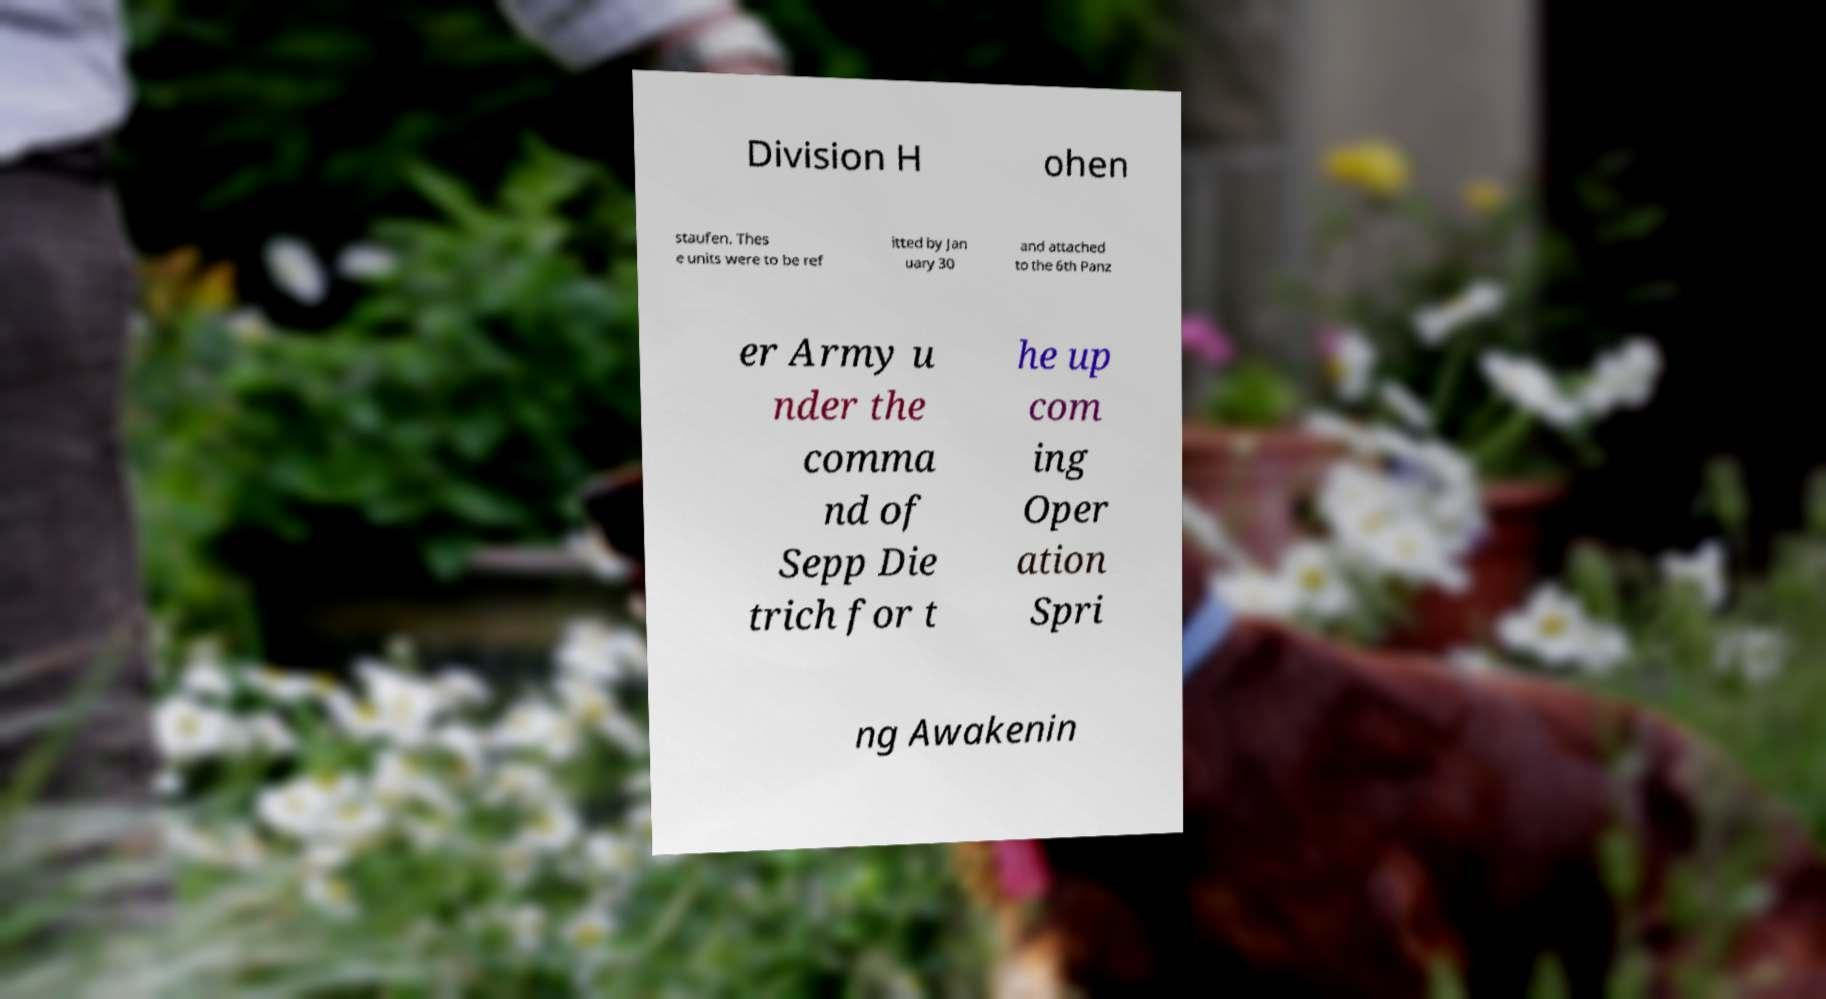Could you extract and type out the text from this image? Division H ohen staufen. Thes e units were to be ref itted by Jan uary 30 and attached to the 6th Panz er Army u nder the comma nd of Sepp Die trich for t he up com ing Oper ation Spri ng Awakenin 